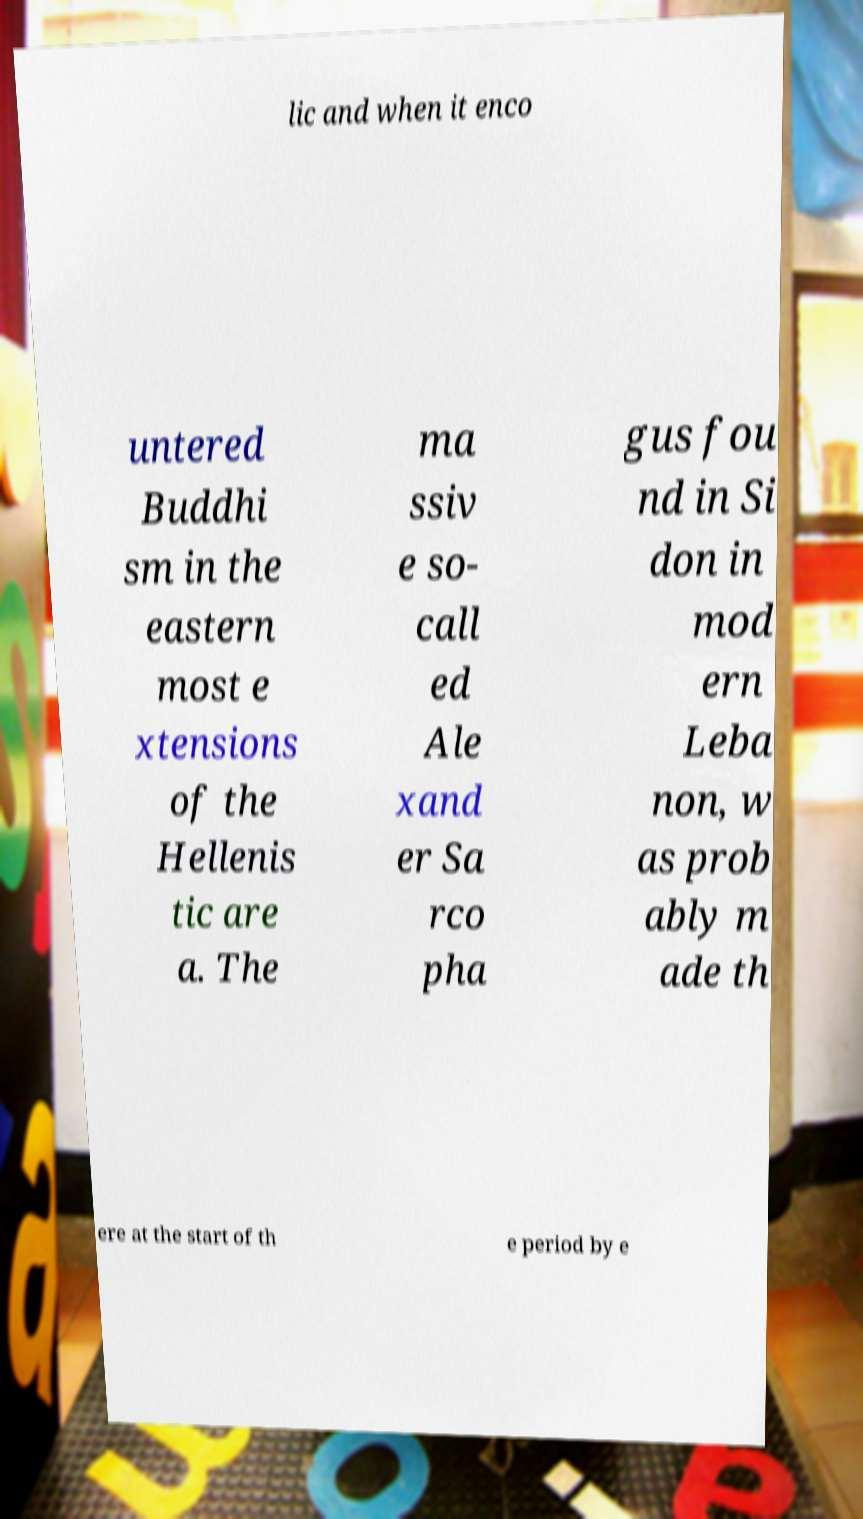What messages or text are displayed in this image? I need them in a readable, typed format. lic and when it enco untered Buddhi sm in the eastern most e xtensions of the Hellenis tic are a. The ma ssiv e so- call ed Ale xand er Sa rco pha gus fou nd in Si don in mod ern Leba non, w as prob ably m ade th ere at the start of th e period by e 